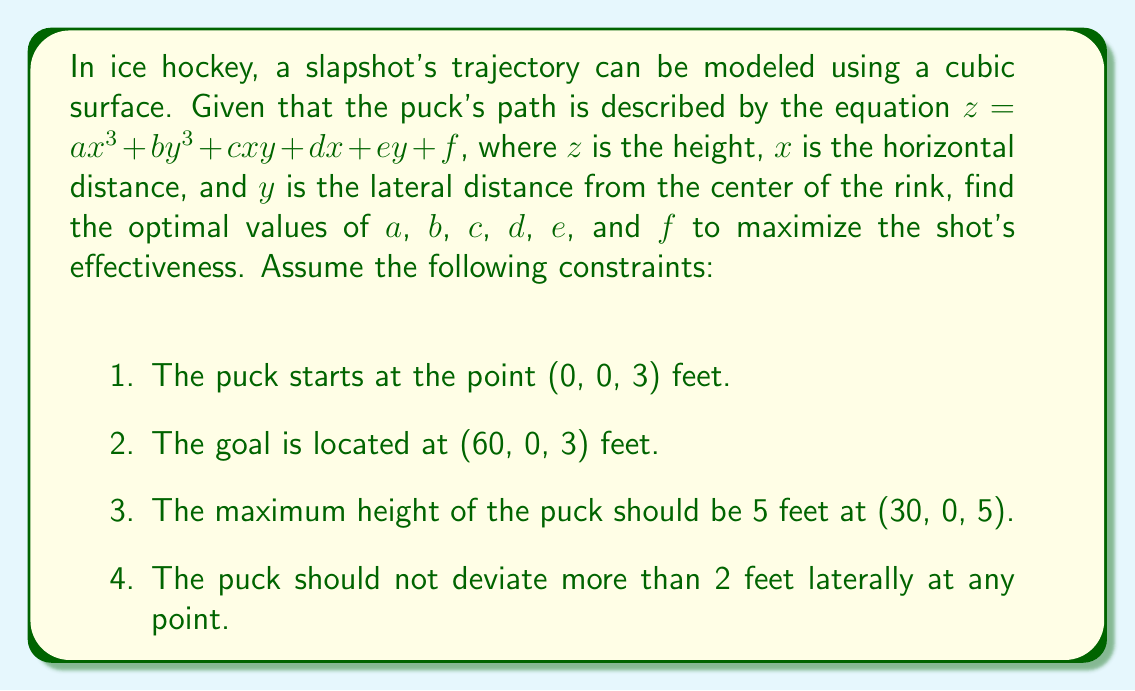Can you answer this question? Let's approach this step-by-step:

1) First, we use the starting point condition:
   At (0, 0, 3): $3 = f$

2) The goal location condition:
   At (60, 0, 3): $3 = a(60^3) + d(60) + 3$
   $0 = 216000a + 60d$

3) The maximum height condition:
   At (30, 0, 5): $5 = a(30^3) + d(30) + 3$
   $2 = 27000a + 30d$

4) To ensure the puck doesn't deviate more than 2 feet laterally, we set $b = 0$ and $c = 0$. This makes the trajectory symmetric about the $x$-axis.

5) The $e$ coefficient becomes irrelevant due to the symmetry, so we can set $e = 0$.

6) Now we have a system of equations:
   $216000a + 60d = 0$
   $27000a + 30d = 2$

7) Solving this system:
   $d = -3600a$
   $27000a - 108000a = 2$
   $-81000a = 2$
   $a = -\frac{1}{40500}$

8) Substituting back:
   $d = -3600 * (-\frac{1}{40500}) = \frac{8}{90}$

Therefore, the optimal cubic surface equation is:

$$z = -\frac{1}{40500}x^3 + \frac{8}{90}x + 3$$

This equation satisfies all the given conditions and provides an optimal trajectory for the slapshot.
Answer: $z = -\frac{1}{40500}x^3 + \frac{8}{90}x + 3$ 